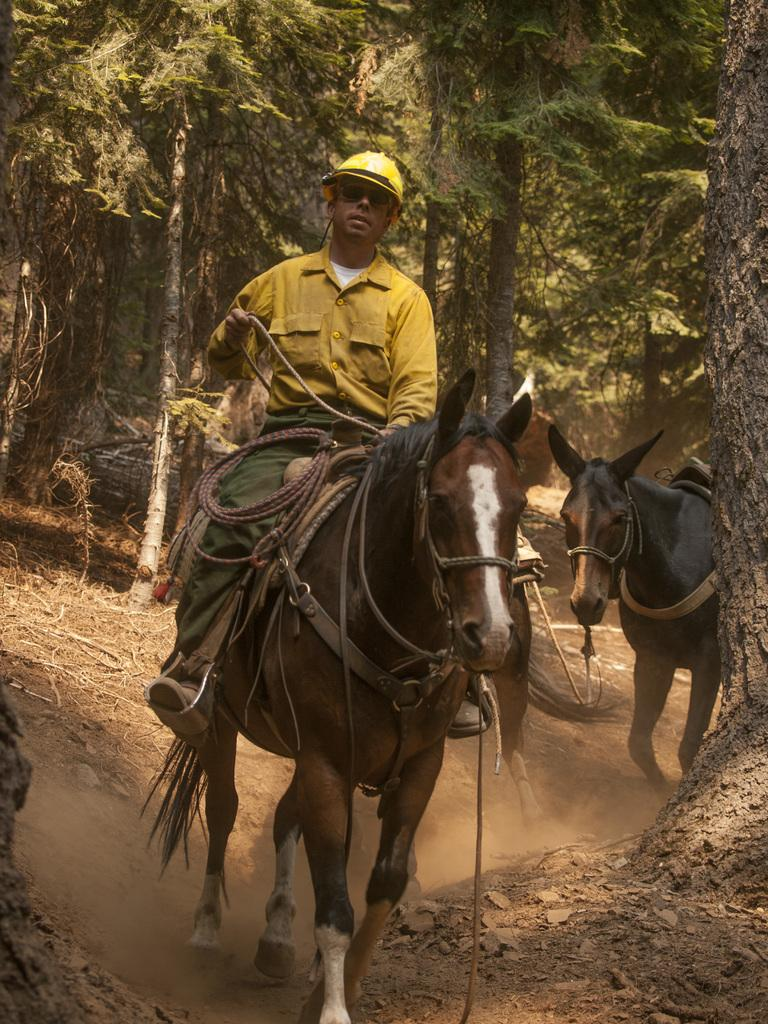What is the main subject of the image? There is a person in the image. What is the person doing in the image? The person is riding a horse. What is the person holding while riding the horse? The person is holding a rope. What can be seen in the background of the image? There are trees and horses in the background of the image. What type of shelf can be seen in the image? There is no shelf present in the image. What sound can be heard coming from the horses in the image? The image is a still picture, so no sounds can be heard. 